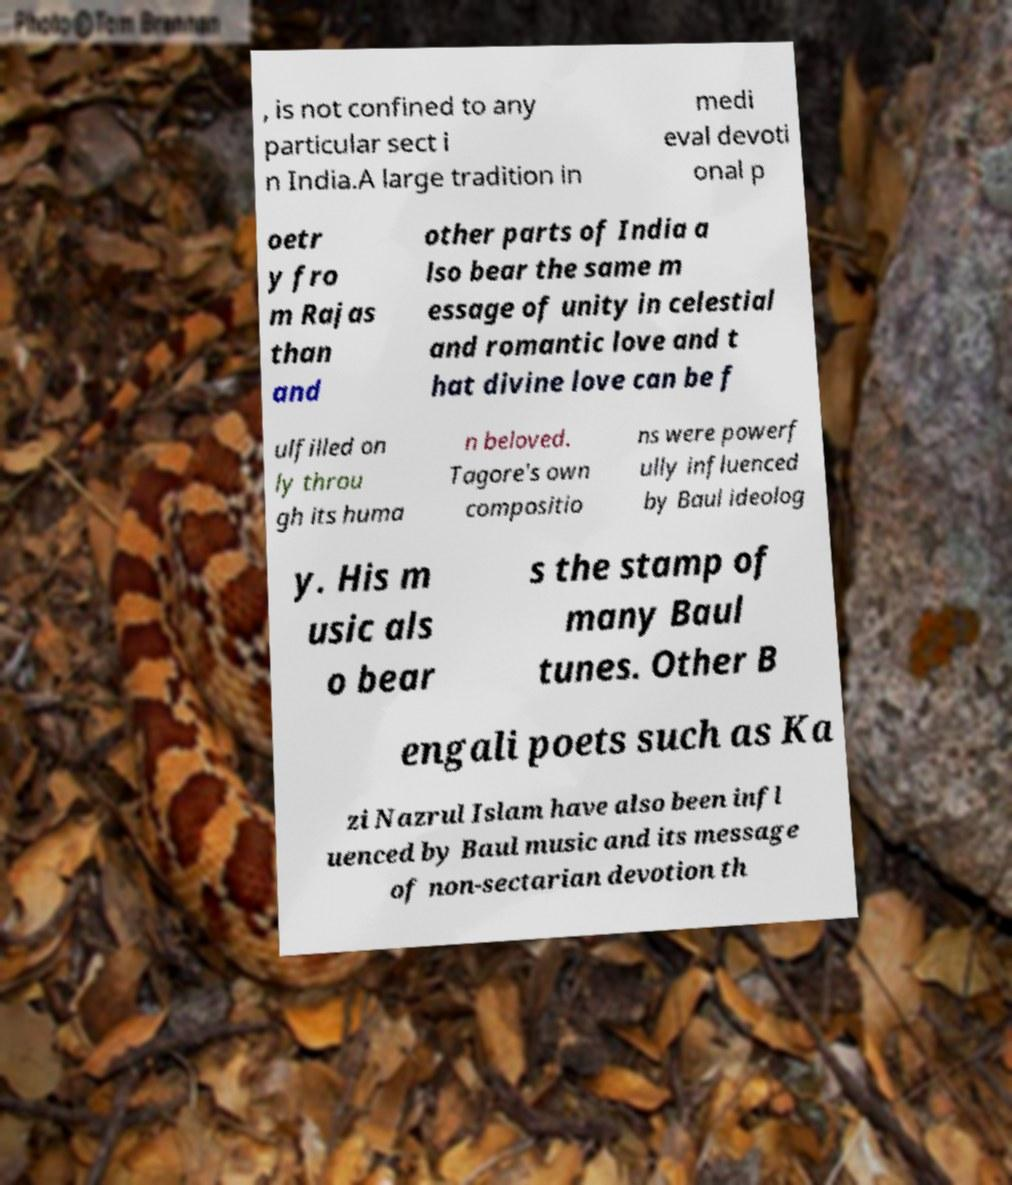Could you assist in decoding the text presented in this image and type it out clearly? , is not confined to any particular sect i n India.A large tradition in medi eval devoti onal p oetr y fro m Rajas than and other parts of India a lso bear the same m essage of unity in celestial and romantic love and t hat divine love can be f ulfilled on ly throu gh its huma n beloved. Tagore's own compositio ns were powerf ully influenced by Baul ideolog y. His m usic als o bear s the stamp of many Baul tunes. Other B engali poets such as Ka zi Nazrul Islam have also been infl uenced by Baul music and its message of non-sectarian devotion th 